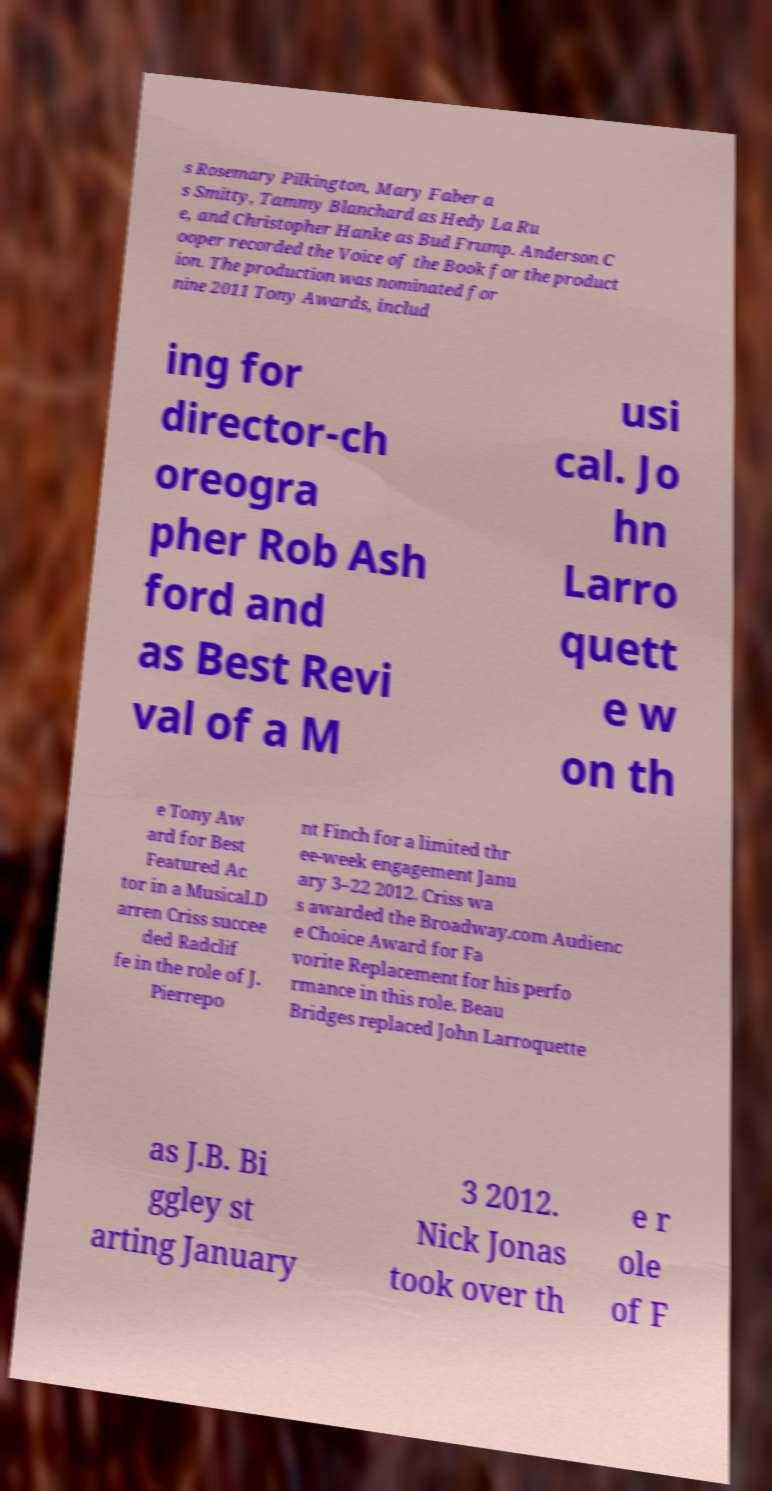Please read and relay the text visible in this image. What does it say? s Rosemary Pilkington, Mary Faber a s Smitty, Tammy Blanchard as Hedy La Ru e, and Christopher Hanke as Bud Frump. Anderson C ooper recorded the Voice of the Book for the product ion. The production was nominated for nine 2011 Tony Awards, includ ing for director-ch oreogra pher Rob Ash ford and as Best Revi val of a M usi cal. Jo hn Larro quett e w on th e Tony Aw ard for Best Featured Ac tor in a Musical.D arren Criss succee ded Radclif fe in the role of J. Pierrepo nt Finch for a limited thr ee-week engagement Janu ary 3–22 2012. Criss wa s awarded the Broadway.com Audienc e Choice Award for Fa vorite Replacement for his perfo rmance in this role. Beau Bridges replaced John Larroquette as J.B. Bi ggley st arting January 3 2012. Nick Jonas took over th e r ole of F 